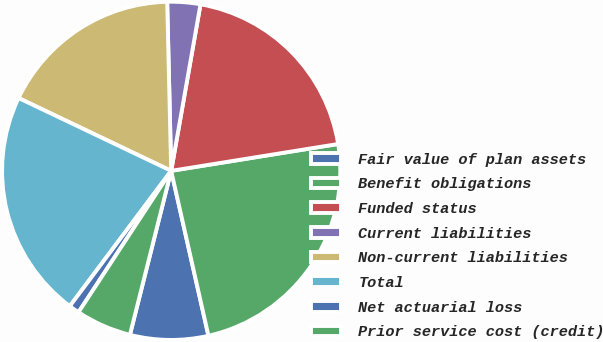Convert chart to OTSL. <chart><loc_0><loc_0><loc_500><loc_500><pie_chart><fcel>Fair value of plan assets<fcel>Benefit obligations<fcel>Funded status<fcel>Current liabilities<fcel>Non-current liabilities<fcel>Total<fcel>Net actuarial loss<fcel>Prior service cost (credit)<nl><fcel>7.46%<fcel>24.0%<fcel>19.69%<fcel>3.15%<fcel>17.54%<fcel>21.85%<fcel>1.0%<fcel>5.31%<nl></chart> 